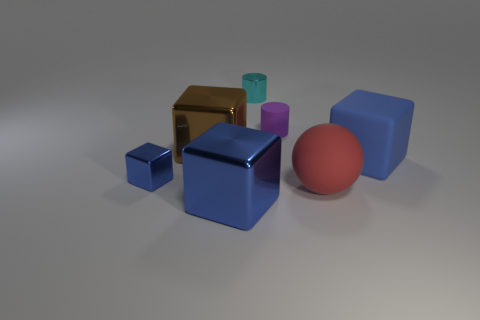Subtract all brown spheres. How many blue blocks are left? 3 Subtract all green cubes. Subtract all green cylinders. How many cubes are left? 4 Add 1 purple matte objects. How many objects exist? 8 Subtract all cylinders. How many objects are left? 5 Add 7 tiny objects. How many tiny objects exist? 10 Subtract 0 green cylinders. How many objects are left? 7 Subtract all purple rubber objects. Subtract all tiny metal cubes. How many objects are left? 5 Add 7 big blocks. How many big blocks are left? 10 